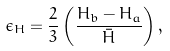<formula> <loc_0><loc_0><loc_500><loc_500>\epsilon _ { H } = \frac { 2 } { 3 } \left ( \frac { H _ { b } - H _ { a } } { \bar { H } } \right ) ,</formula> 